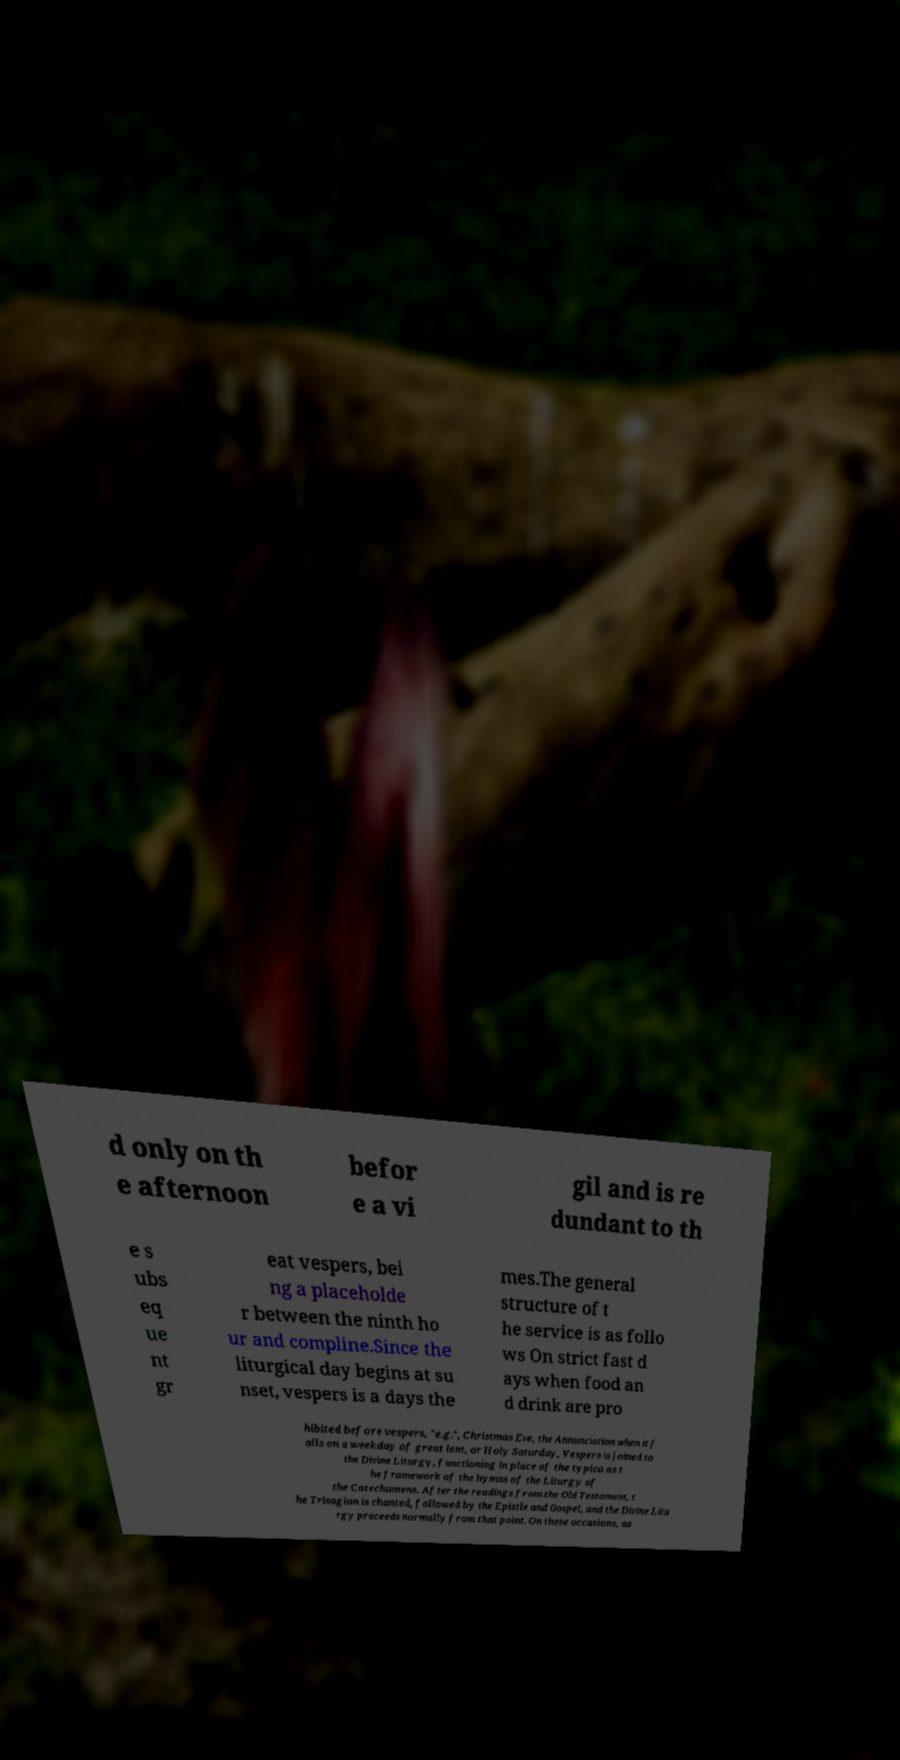Please read and relay the text visible in this image. What does it say? d only on th e afternoon befor e a vi gil and is re dundant to th e s ubs eq ue nt gr eat vespers, bei ng a placeholde r between the ninth ho ur and compline.Since the liturgical day begins at su nset, vespers is a days the mes.The general structure of t he service is as follo ws On strict fast d ays when food an d drink are pro hibited before vespers, "e.g.", Christmas Eve, the Annunciation when it f alls on a weekday of great lent, or Holy Saturday, Vespers is joined to the Divine Liturgy, functioning in place of the typica as t he framework of the hymns of the Liturgy of the Catechumens. After the readings from the Old Testament, t he Trisagion is chanted, followed by the Epistle and Gospel, and the Divine Litu rgy proceeds normally from that point. On these occasions, as 